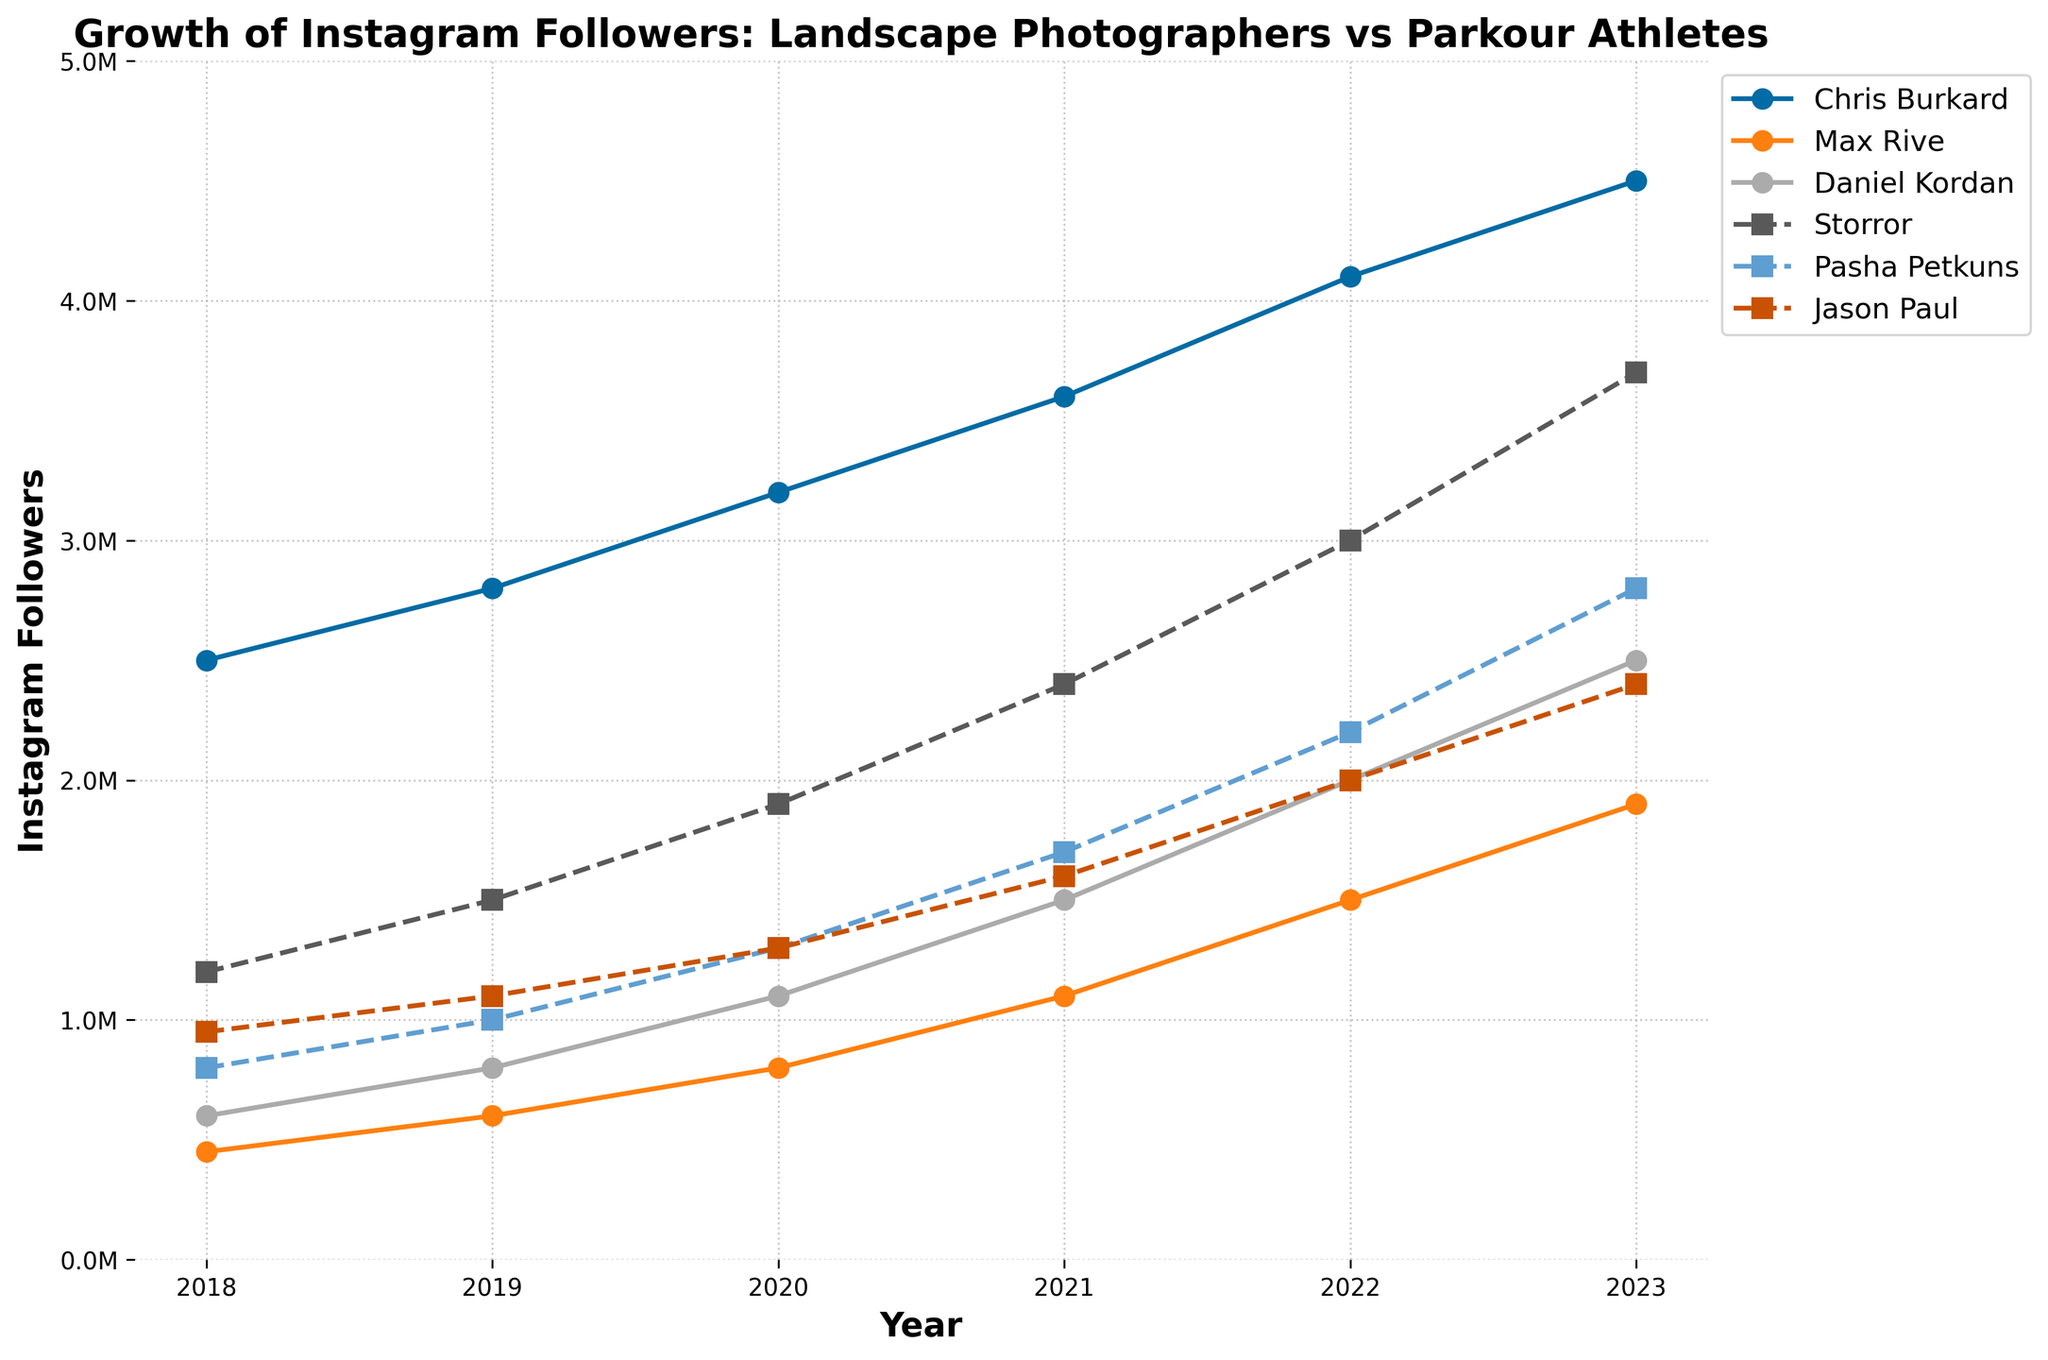what was the difference in followers between Storror and Chris Burkard in 2023? In 2023, Storror had 3,700,000 followers and Chris Burkard had 4,500,000 followers. The difference in followers is 4,500,000 - 3,700,000 = 800,000
Answer: 800,000 Which year did Max Rive surpass 1 million followers? By referring to the figure, Max Rive reached 1 million followers in 2021. This is the first year on the chart where his followers are shown as above 1 million.
Answer: 2021 Who had the slowest growth rate from 2022 to 2023? By looking at the differences in follower counts from 2022 to 2023: Chris Burkard grew by 400,000, Max Rive by 400,000, Daniel Kordan by 500,000, Storror by 700,000, Pasha Petkuns by 600,000, and Jason Paul by 400,000, meaning Max Rive, Chris Burkard, and Jason Paul had the slowest growth rate of 400,000 followers each
Answer: Max Rive, Chris Burkard, and Jason Paul Which parkour athlete had the highest followers in 2020? In 2020, the parkour athletes are: Storror with 1,900,000 followers, Pasha Petkuns with 1,300,000 followers, and Jason Paul with 1,300,000 followers. Storror had the highest number of followers among them.
Answer: Storror What was the average followers for Daniel Kordan from 2018 to 2023? Daniel Kordan's followers each year were: 600,000 in 2018, 800,000 in 2019, 1,100,000 in 2020, 1,500,000 in 2021, 2,000,000 in 2022, and 2,500,000 in 2023. Summing these gives 8,500,000. The average is 8,500,000 / 6 = 1,416,667
Answer: 1,416,667 When did Chris Burkard reach 4 million followers? According to the plot, Chris Burkard reached 4 million followers in 2022.
Answer: 2022 